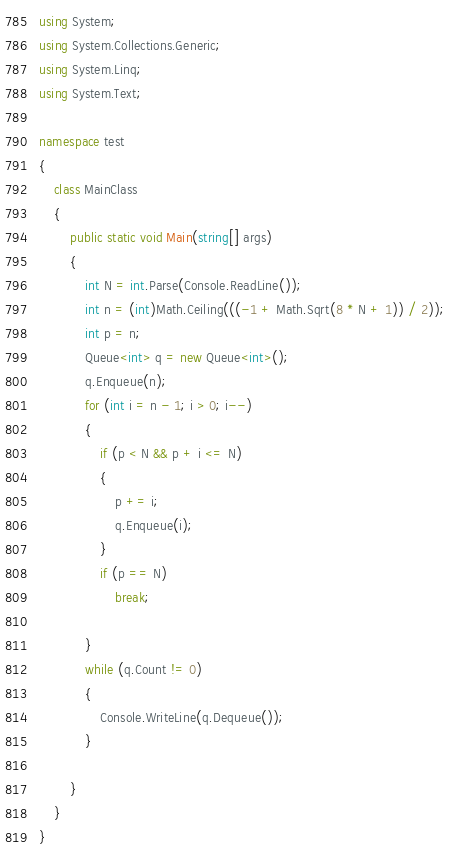Convert code to text. <code><loc_0><loc_0><loc_500><loc_500><_C#_>using System;
using System.Collections.Generic;
using System.Linq;
using System.Text;

namespace test
{
	class MainClass
	{
		public static void Main(string[] args)
		{
			int N = int.Parse(Console.ReadLine());
			int n = (int)Math.Ceiling(((-1 + Math.Sqrt(8 * N + 1)) / 2));
			int p = n;
			Queue<int> q = new Queue<int>();
			q.Enqueue(n);
			for (int i = n - 1; i > 0; i--)
			{
				if (p < N && p + i <= N)
				{
					p += i;
					q.Enqueue(i);
				}
				if (p == N)
					break;
				
			}
			while (q.Count != 0)
			{
				Console.WriteLine(q.Dequeue());
			}

		}
	}
}
</code> 